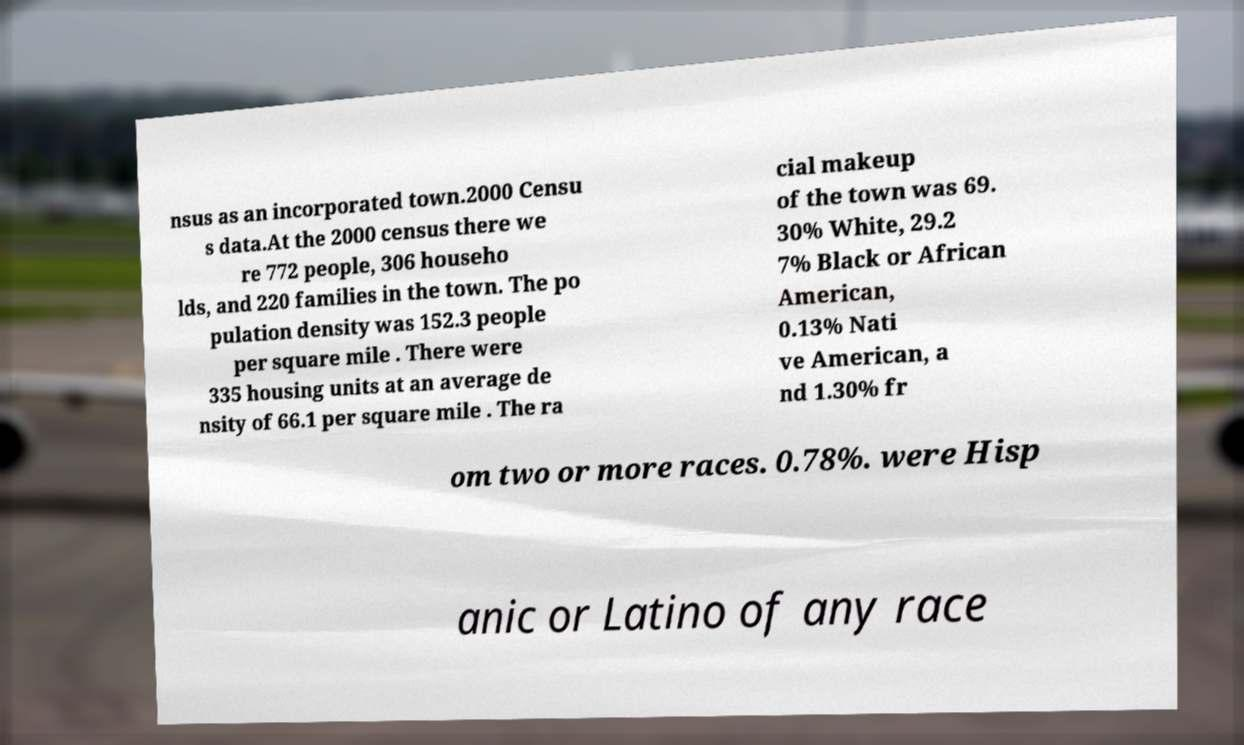Please read and relay the text visible in this image. What does it say? nsus as an incorporated town.2000 Censu s data.At the 2000 census there we re 772 people, 306 househo lds, and 220 families in the town. The po pulation density was 152.3 people per square mile . There were 335 housing units at an average de nsity of 66.1 per square mile . The ra cial makeup of the town was 69. 30% White, 29.2 7% Black or African American, 0.13% Nati ve American, a nd 1.30% fr om two or more races. 0.78%. were Hisp anic or Latino of any race 